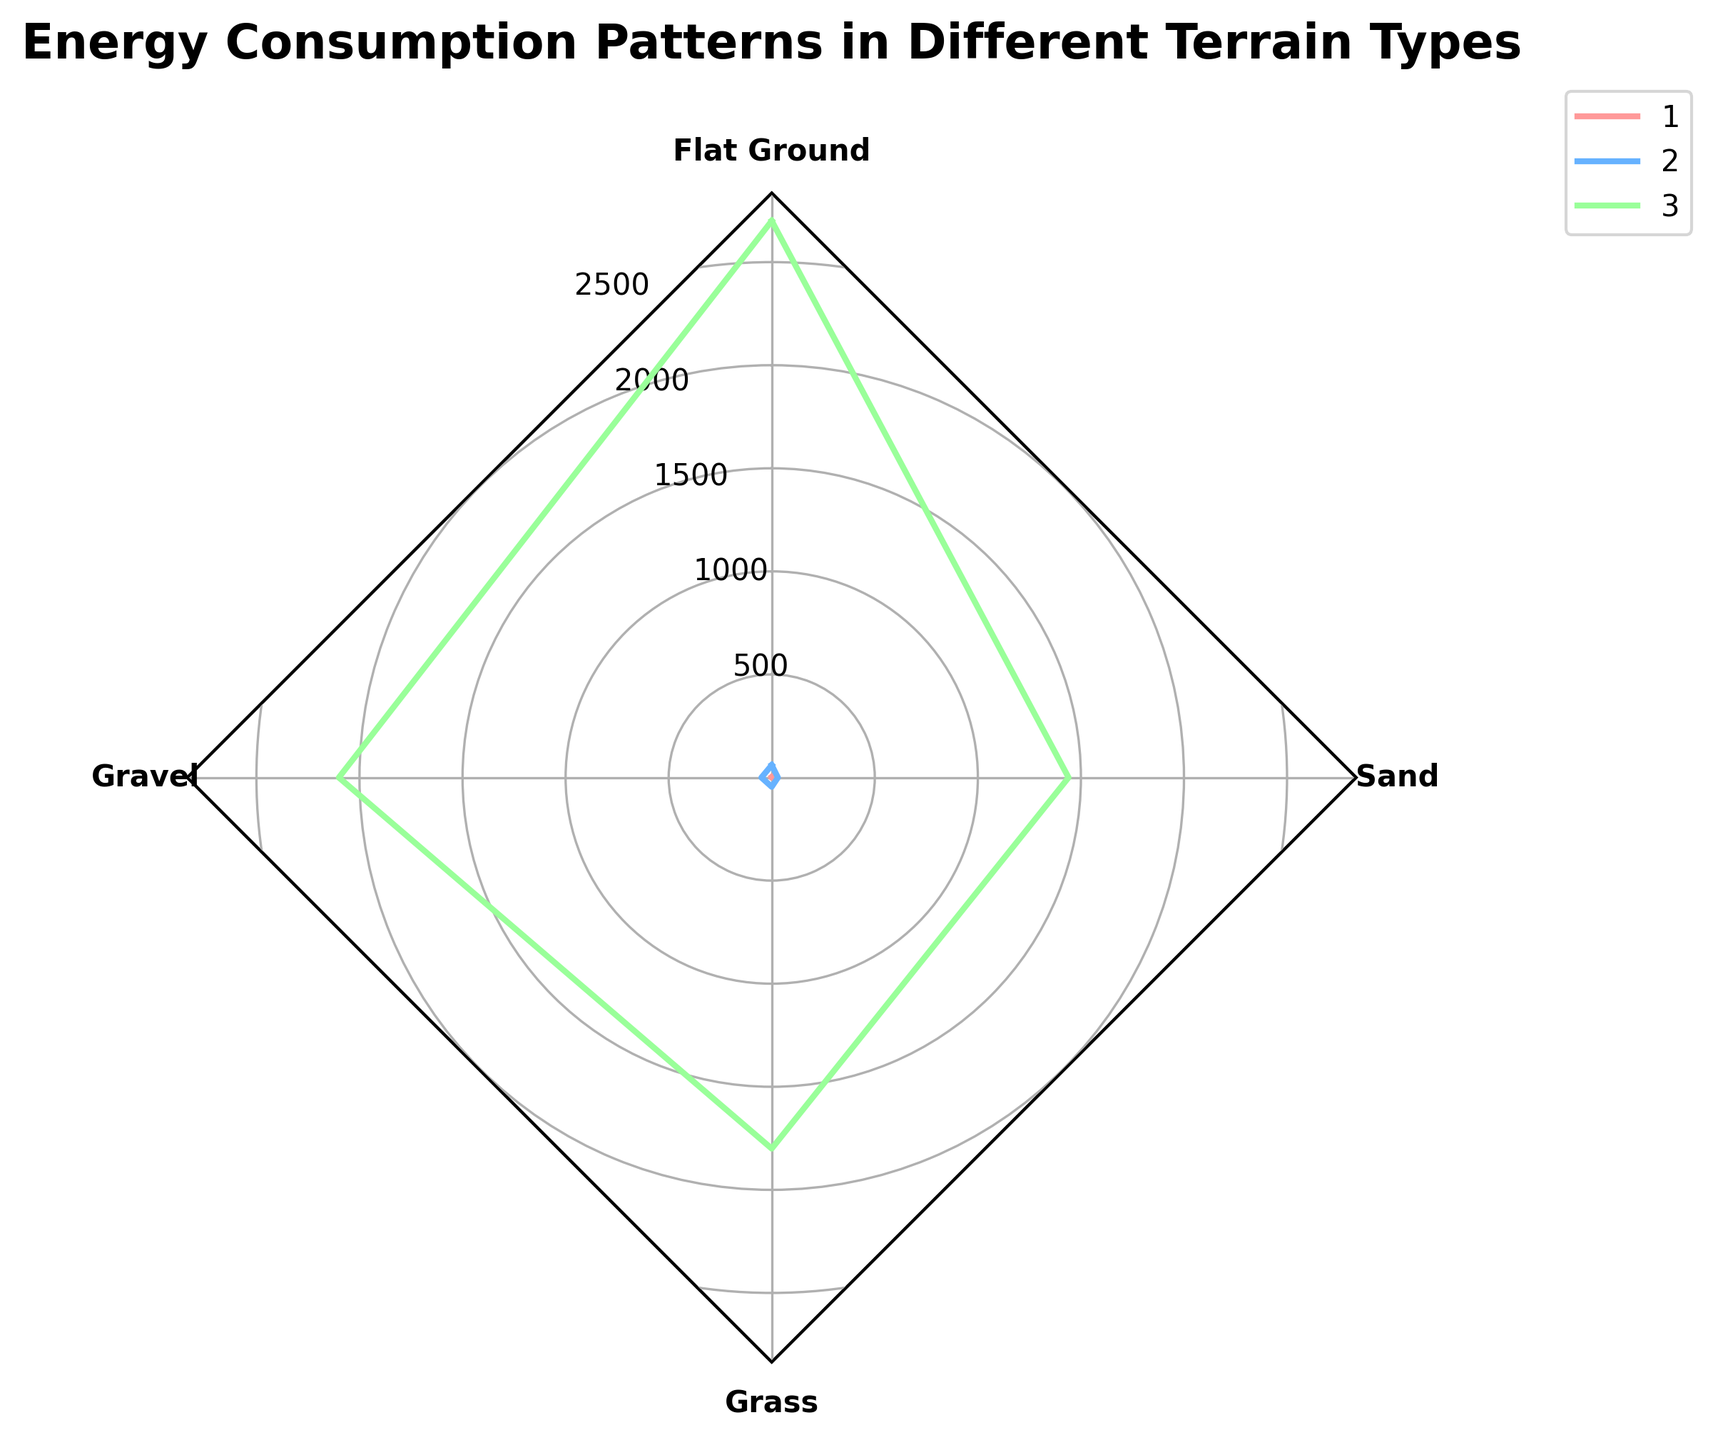What is the title of the radar chart? The title is located above the radar chart and typically provides the main topic or subject of the visualized data.
Answer: Energy Consumption Patterns in Different Terrain Types How many different terrains are compared in the radar chart? The radar chart shows each terrain type on different axes, which can be counted directly.
Answer: 4 Which terrain shows the highest energy consumption per meter? Look for the highest value on the "Energy Consumption (Joules per Meter)" axis. Find the terrain label at the end of the axis' path.
Answer: Sand Compare the distance covered in 30 minutes between gravel and grass. Which terrain allows covering a greater distance? Check the respective "Distance Covered in 30 Minutes (Meters)" values on the radar chart for both terrains. Gravel and grass points can be visually compared.
Answer: Gravel How does the battery life per kilometer for robots on flat ground compare with that on sand? Locate the "Battery Life (Minutes per Kilometer)" axis and compare values for flat ground and sand terrains. Battery life for sand is much lower than that for flat ground.
Answer: Flat ground has longer battery life Among the terrains shown, which one is the slowest in terms of speed? The axis labeled "Speed (Meters per Second)" shows the corresponding speeds. Identifying the lowest point on this axis will provide the answer.
Answer: Sand Calculate the average energy consumption per meter across all terrains displayed. Sum the values for "Energy Consumption (Joules per Meter)" for all terrains: 120 + 150 + 180 + 210 = 660. Divide by 4 (number of terrains): 660 / 4 = 165.
Answer: 165 Joules per Meter Which terrain demonstrates the best balance between speed and battery life? Evaluate the radar chart by comparing terrains that have balanced values on both "Speed (Meters per Second)" and "Battery Life (Minutes per Kilometer)" axes.
Answer: Flat ground If the energy consumption pattern changes so that each terrain requires 10% more energy per meter, what would be the new value for gravel? Original energy consumption for gravel is 150 Joules per Meter. A 10% increase: 150 * 1.10 = 165 Joules per Meter.
Answer: 165 Joules per Meter Which terrain type achieves the greatest distance covered in 30 minutes? Look at the "Distance Covered in 30 Minutes (Meters)" axis and identify the highest value corresponding to the terrain type.
Answer: Flat ground 